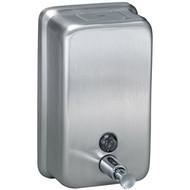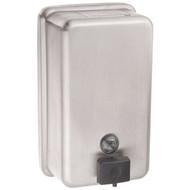The first image is the image on the left, the second image is the image on the right. Examine the images to the left and right. Is the description "A restroom interior contains a counter with at least three identical white sinks." accurate? Answer yes or no. No. The first image is the image on the left, the second image is the image on the right. Given the left and right images, does the statement "A person is pushing the dispenser in the image on the left." hold true? Answer yes or no. No. 